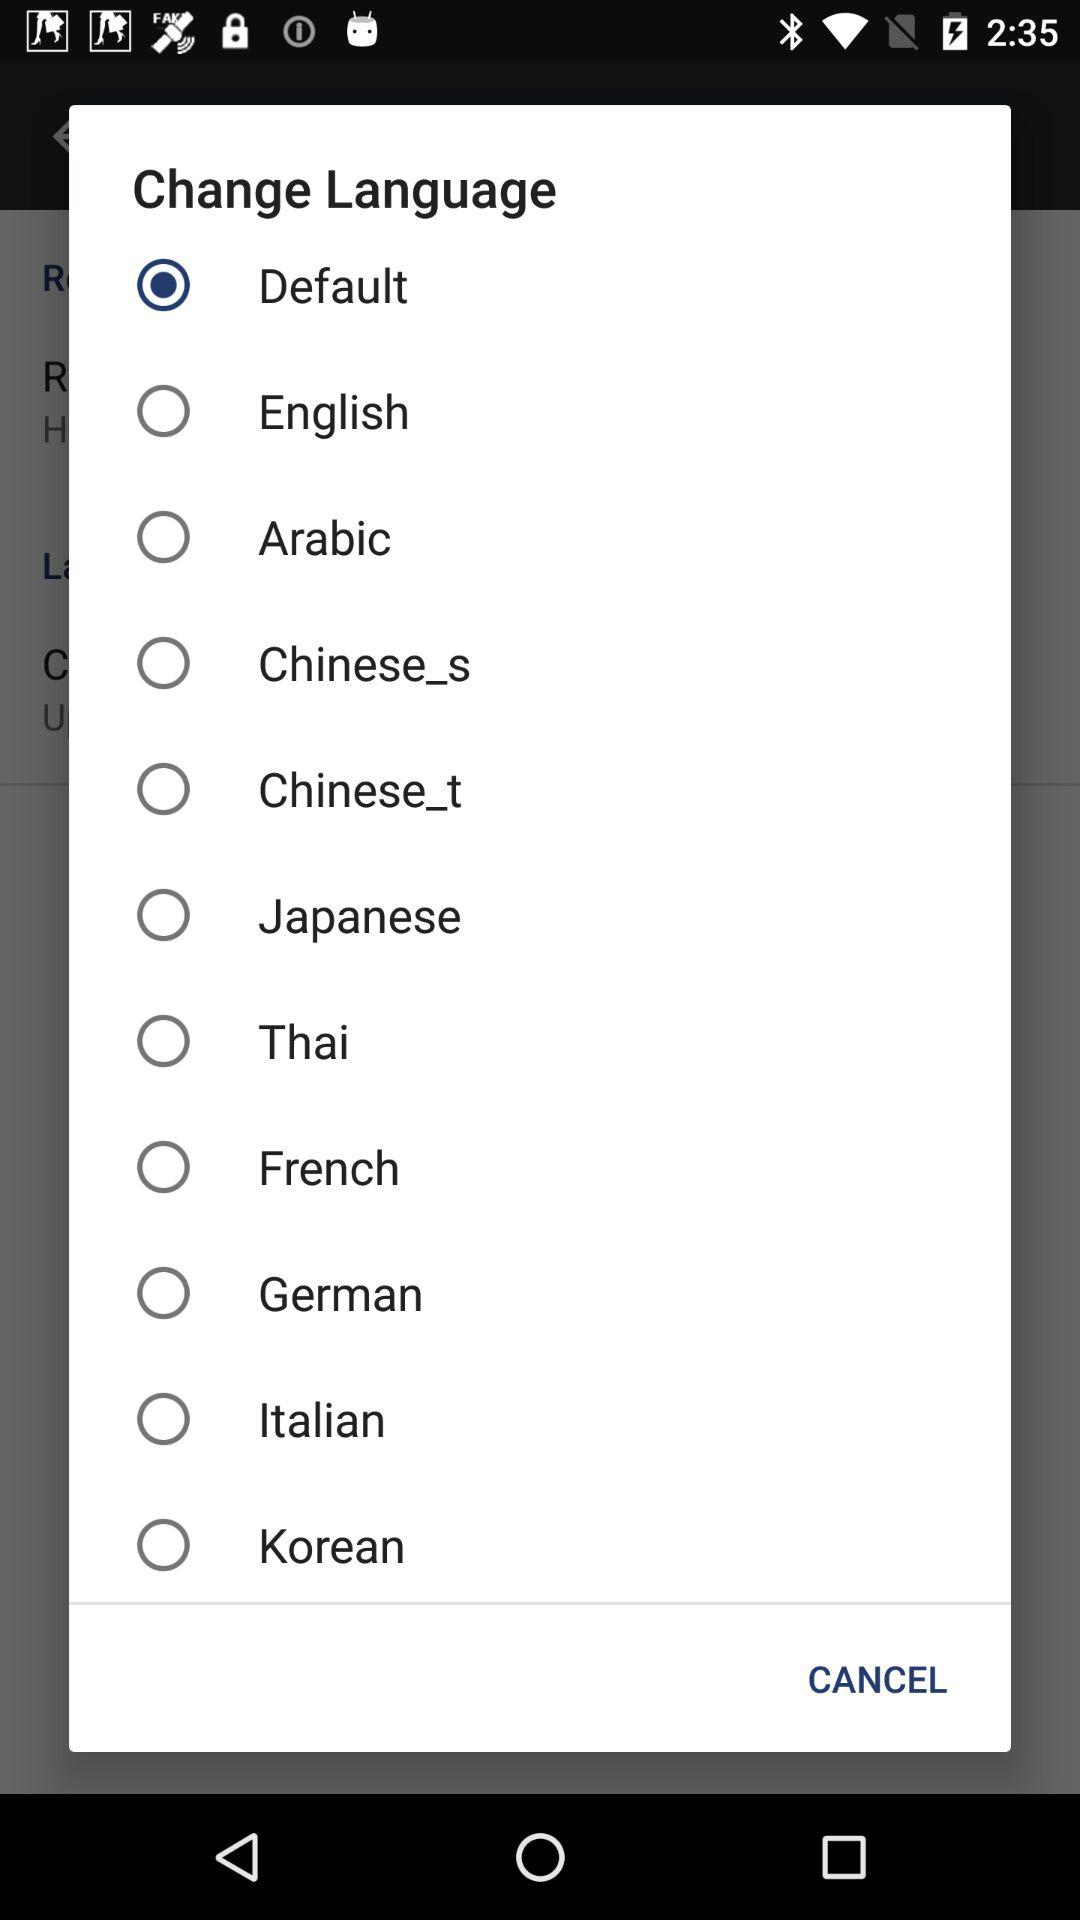What option has been selected in "Change Language"? The selected option is "Default". 